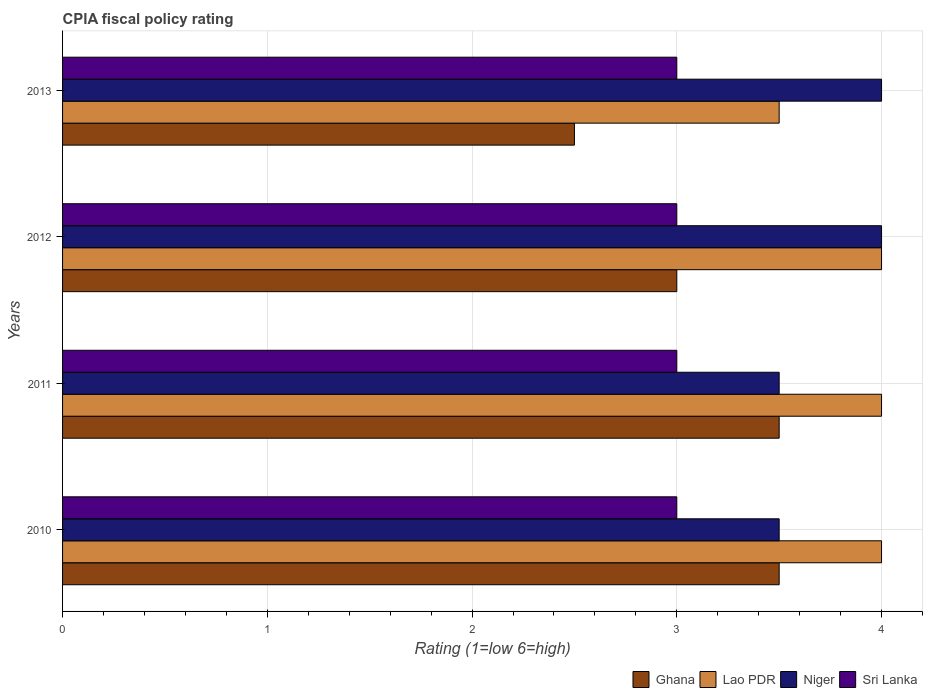How many different coloured bars are there?
Offer a very short reply. 4. How many groups of bars are there?
Provide a succinct answer. 4. Are the number of bars per tick equal to the number of legend labels?
Your answer should be compact. Yes. In how many cases, is the number of bars for a given year not equal to the number of legend labels?
Your answer should be compact. 0. Across all years, what is the minimum CPIA rating in Sri Lanka?
Offer a terse response. 3. What is the total CPIA rating in Sri Lanka in the graph?
Your response must be concise. 12. What is the difference between the CPIA rating in Niger in 2013 and the CPIA rating in Lao PDR in 2012?
Your answer should be compact. 0. Is the CPIA rating in Sri Lanka in 2010 less than that in 2013?
Provide a succinct answer. No. Is the difference between the CPIA rating in Niger in 2010 and 2011 greater than the difference between the CPIA rating in Ghana in 2010 and 2011?
Your answer should be compact. No. What is the difference between the highest and the second highest CPIA rating in Niger?
Offer a terse response. 0. What is the difference between the highest and the lowest CPIA rating in Ghana?
Your answer should be very brief. 1. In how many years, is the CPIA rating in Lao PDR greater than the average CPIA rating in Lao PDR taken over all years?
Ensure brevity in your answer.  3. Is it the case that in every year, the sum of the CPIA rating in Ghana and CPIA rating in Sri Lanka is greater than the sum of CPIA rating in Niger and CPIA rating in Lao PDR?
Make the answer very short. No. What does the 3rd bar from the top in 2011 represents?
Ensure brevity in your answer.  Lao PDR. What does the 3rd bar from the bottom in 2012 represents?
Provide a succinct answer. Niger. Are all the bars in the graph horizontal?
Provide a succinct answer. Yes. Does the graph contain grids?
Ensure brevity in your answer.  Yes. What is the title of the graph?
Offer a very short reply. CPIA fiscal policy rating. Does "Aruba" appear as one of the legend labels in the graph?
Offer a very short reply. No. What is the Rating (1=low 6=high) in Ghana in 2010?
Give a very brief answer. 3.5. What is the Rating (1=low 6=high) of Lao PDR in 2010?
Your answer should be compact. 4. What is the Rating (1=low 6=high) in Niger in 2010?
Ensure brevity in your answer.  3.5. What is the Rating (1=low 6=high) in Sri Lanka in 2010?
Your answer should be very brief. 3. What is the Rating (1=low 6=high) of Lao PDR in 2011?
Your answer should be very brief. 4. What is the Rating (1=low 6=high) in Sri Lanka in 2011?
Offer a terse response. 3. What is the Rating (1=low 6=high) of Ghana in 2012?
Your answer should be compact. 3. What is the Rating (1=low 6=high) in Lao PDR in 2012?
Make the answer very short. 4. What is the Rating (1=low 6=high) in Niger in 2012?
Your response must be concise. 4. What is the Rating (1=low 6=high) of Niger in 2013?
Provide a short and direct response. 4. What is the Rating (1=low 6=high) of Sri Lanka in 2013?
Offer a very short reply. 3. Across all years, what is the maximum Rating (1=low 6=high) of Ghana?
Keep it short and to the point. 3.5. Across all years, what is the maximum Rating (1=low 6=high) of Lao PDR?
Ensure brevity in your answer.  4. Across all years, what is the maximum Rating (1=low 6=high) in Sri Lanka?
Provide a succinct answer. 3. What is the total Rating (1=low 6=high) in Ghana in the graph?
Keep it short and to the point. 12.5. What is the total Rating (1=low 6=high) in Lao PDR in the graph?
Offer a very short reply. 15.5. What is the difference between the Rating (1=low 6=high) in Ghana in 2010 and that in 2011?
Your response must be concise. 0. What is the difference between the Rating (1=low 6=high) of Sri Lanka in 2010 and that in 2011?
Keep it short and to the point. 0. What is the difference between the Rating (1=low 6=high) of Lao PDR in 2010 and that in 2013?
Keep it short and to the point. 0.5. What is the difference between the Rating (1=low 6=high) of Niger in 2010 and that in 2013?
Give a very brief answer. -0.5. What is the difference between the Rating (1=low 6=high) of Niger in 2011 and that in 2012?
Provide a short and direct response. -0.5. What is the difference between the Rating (1=low 6=high) of Sri Lanka in 2011 and that in 2012?
Give a very brief answer. 0. What is the difference between the Rating (1=low 6=high) of Ghana in 2011 and that in 2013?
Keep it short and to the point. 1. What is the difference between the Rating (1=low 6=high) in Sri Lanka in 2011 and that in 2013?
Your answer should be compact. 0. What is the difference between the Rating (1=low 6=high) of Lao PDR in 2012 and that in 2013?
Your answer should be very brief. 0.5. What is the difference between the Rating (1=low 6=high) of Niger in 2012 and that in 2013?
Provide a succinct answer. 0. What is the difference between the Rating (1=low 6=high) in Sri Lanka in 2012 and that in 2013?
Make the answer very short. 0. What is the difference between the Rating (1=low 6=high) of Ghana in 2010 and the Rating (1=low 6=high) of Lao PDR in 2011?
Your answer should be very brief. -0.5. What is the difference between the Rating (1=low 6=high) in Ghana in 2010 and the Rating (1=low 6=high) in Niger in 2011?
Make the answer very short. 0. What is the difference between the Rating (1=low 6=high) in Lao PDR in 2010 and the Rating (1=low 6=high) in Niger in 2011?
Make the answer very short. 0.5. What is the difference between the Rating (1=low 6=high) in Lao PDR in 2010 and the Rating (1=low 6=high) in Sri Lanka in 2011?
Provide a short and direct response. 1. What is the difference between the Rating (1=low 6=high) in Ghana in 2010 and the Rating (1=low 6=high) in Lao PDR in 2012?
Give a very brief answer. -0.5. What is the difference between the Rating (1=low 6=high) of Lao PDR in 2010 and the Rating (1=low 6=high) of Sri Lanka in 2012?
Provide a succinct answer. 1. What is the difference between the Rating (1=low 6=high) in Lao PDR in 2010 and the Rating (1=low 6=high) in Niger in 2013?
Your response must be concise. 0. What is the difference between the Rating (1=low 6=high) in Ghana in 2011 and the Rating (1=low 6=high) in Niger in 2012?
Offer a very short reply. -0.5. What is the difference between the Rating (1=low 6=high) of Ghana in 2011 and the Rating (1=low 6=high) of Sri Lanka in 2012?
Your response must be concise. 0.5. What is the difference between the Rating (1=low 6=high) in Niger in 2011 and the Rating (1=low 6=high) in Sri Lanka in 2012?
Provide a succinct answer. 0.5. What is the difference between the Rating (1=low 6=high) in Ghana in 2011 and the Rating (1=low 6=high) in Niger in 2013?
Your answer should be compact. -0.5. What is the difference between the Rating (1=low 6=high) in Lao PDR in 2011 and the Rating (1=low 6=high) in Niger in 2013?
Offer a very short reply. 0. What is the difference between the Rating (1=low 6=high) in Ghana in 2012 and the Rating (1=low 6=high) in Niger in 2013?
Provide a short and direct response. -1. What is the difference between the Rating (1=low 6=high) in Ghana in 2012 and the Rating (1=low 6=high) in Sri Lanka in 2013?
Keep it short and to the point. 0. What is the difference between the Rating (1=low 6=high) in Lao PDR in 2012 and the Rating (1=low 6=high) in Niger in 2013?
Your answer should be very brief. 0. What is the difference between the Rating (1=low 6=high) of Lao PDR in 2012 and the Rating (1=low 6=high) of Sri Lanka in 2013?
Make the answer very short. 1. What is the difference between the Rating (1=low 6=high) of Niger in 2012 and the Rating (1=low 6=high) of Sri Lanka in 2013?
Your response must be concise. 1. What is the average Rating (1=low 6=high) of Ghana per year?
Make the answer very short. 3.12. What is the average Rating (1=low 6=high) in Lao PDR per year?
Ensure brevity in your answer.  3.88. What is the average Rating (1=low 6=high) in Niger per year?
Give a very brief answer. 3.75. In the year 2010, what is the difference between the Rating (1=low 6=high) of Lao PDR and Rating (1=low 6=high) of Niger?
Give a very brief answer. 0.5. In the year 2010, what is the difference between the Rating (1=low 6=high) of Lao PDR and Rating (1=low 6=high) of Sri Lanka?
Make the answer very short. 1. In the year 2010, what is the difference between the Rating (1=low 6=high) of Niger and Rating (1=low 6=high) of Sri Lanka?
Ensure brevity in your answer.  0.5. In the year 2011, what is the difference between the Rating (1=low 6=high) of Ghana and Rating (1=low 6=high) of Niger?
Offer a terse response. 0. In the year 2011, what is the difference between the Rating (1=low 6=high) in Ghana and Rating (1=low 6=high) in Sri Lanka?
Your response must be concise. 0.5. In the year 2011, what is the difference between the Rating (1=low 6=high) of Lao PDR and Rating (1=low 6=high) of Niger?
Give a very brief answer. 0.5. In the year 2011, what is the difference between the Rating (1=low 6=high) of Lao PDR and Rating (1=low 6=high) of Sri Lanka?
Offer a very short reply. 1. In the year 2011, what is the difference between the Rating (1=low 6=high) of Niger and Rating (1=low 6=high) of Sri Lanka?
Offer a very short reply. 0.5. In the year 2012, what is the difference between the Rating (1=low 6=high) of Ghana and Rating (1=low 6=high) of Lao PDR?
Provide a short and direct response. -1. In the year 2012, what is the difference between the Rating (1=low 6=high) of Lao PDR and Rating (1=low 6=high) of Niger?
Provide a succinct answer. 0. In the year 2012, what is the difference between the Rating (1=low 6=high) in Niger and Rating (1=low 6=high) in Sri Lanka?
Ensure brevity in your answer.  1. In the year 2013, what is the difference between the Rating (1=low 6=high) in Ghana and Rating (1=low 6=high) in Lao PDR?
Offer a terse response. -1. In the year 2013, what is the difference between the Rating (1=low 6=high) of Ghana and Rating (1=low 6=high) of Niger?
Make the answer very short. -1.5. In the year 2013, what is the difference between the Rating (1=low 6=high) in Lao PDR and Rating (1=low 6=high) in Niger?
Offer a terse response. -0.5. In the year 2013, what is the difference between the Rating (1=low 6=high) in Niger and Rating (1=low 6=high) in Sri Lanka?
Keep it short and to the point. 1. What is the ratio of the Rating (1=low 6=high) of Niger in 2010 to that in 2011?
Make the answer very short. 1. What is the ratio of the Rating (1=low 6=high) in Ghana in 2010 to that in 2012?
Make the answer very short. 1.17. What is the ratio of the Rating (1=low 6=high) in Sri Lanka in 2010 to that in 2012?
Give a very brief answer. 1. What is the ratio of the Rating (1=low 6=high) of Lao PDR in 2010 to that in 2013?
Provide a succinct answer. 1.14. What is the ratio of the Rating (1=low 6=high) in Niger in 2010 to that in 2013?
Provide a succinct answer. 0.88. What is the ratio of the Rating (1=low 6=high) in Lao PDR in 2011 to that in 2012?
Provide a short and direct response. 1. What is the ratio of the Rating (1=low 6=high) in Niger in 2011 to that in 2012?
Keep it short and to the point. 0.88. What is the ratio of the Rating (1=low 6=high) of Sri Lanka in 2011 to that in 2012?
Give a very brief answer. 1. What is the ratio of the Rating (1=low 6=high) of Ghana in 2011 to that in 2013?
Provide a short and direct response. 1.4. What is the ratio of the Rating (1=low 6=high) of Lao PDR in 2011 to that in 2013?
Provide a short and direct response. 1.14. What is the ratio of the Rating (1=low 6=high) of Sri Lanka in 2011 to that in 2013?
Make the answer very short. 1. What is the ratio of the Rating (1=low 6=high) in Ghana in 2012 to that in 2013?
Provide a succinct answer. 1.2. What is the ratio of the Rating (1=low 6=high) in Lao PDR in 2012 to that in 2013?
Provide a short and direct response. 1.14. What is the ratio of the Rating (1=low 6=high) of Niger in 2012 to that in 2013?
Offer a very short reply. 1. What is the difference between the highest and the second highest Rating (1=low 6=high) in Ghana?
Offer a terse response. 0. What is the difference between the highest and the second highest Rating (1=low 6=high) in Niger?
Make the answer very short. 0. What is the difference between the highest and the second highest Rating (1=low 6=high) of Sri Lanka?
Your answer should be compact. 0. What is the difference between the highest and the lowest Rating (1=low 6=high) in Ghana?
Ensure brevity in your answer.  1. 